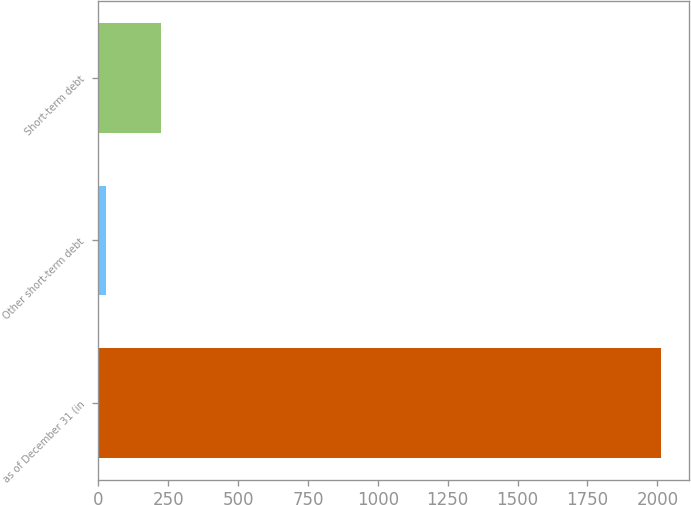Convert chart. <chart><loc_0><loc_0><loc_500><loc_500><bar_chart><fcel>as of December 31 (in<fcel>Other short-term debt<fcel>Short-term debt<nl><fcel>2012<fcel>27<fcel>225.5<nl></chart> 